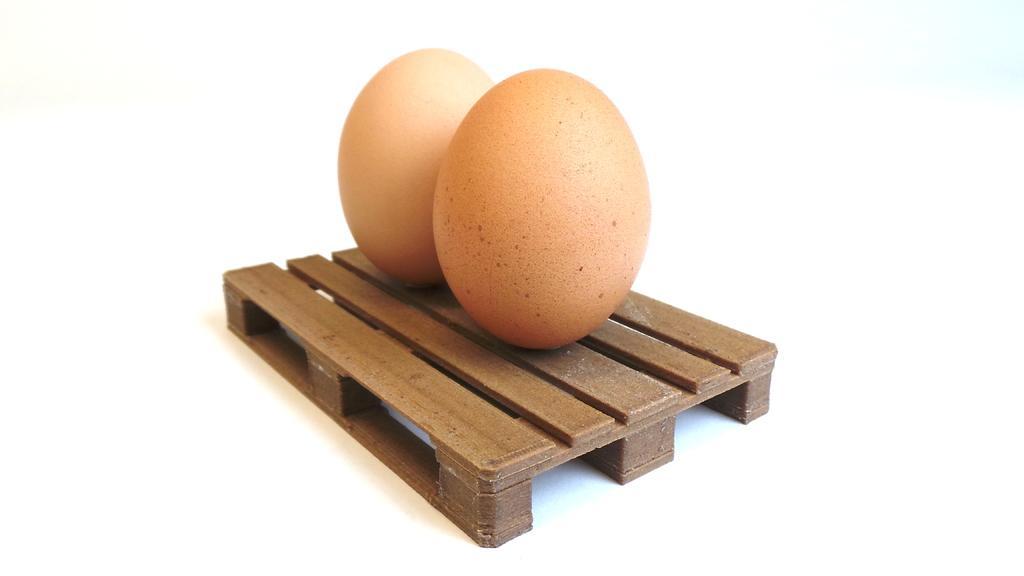Please provide a concise description of this image. In this picture I can see two eggs on the scale model table, and there is white background. 